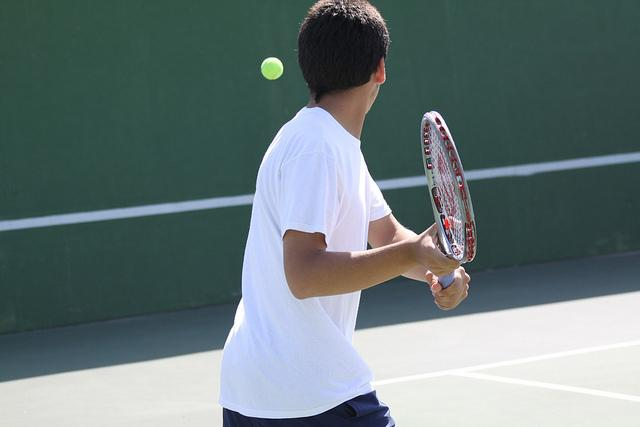What kind of strike is he preparing to do? Please explain your reasoning. backhand. This athlete prepares to swing his racket with knuckles forward. swinging in such a position is known as backhand. 